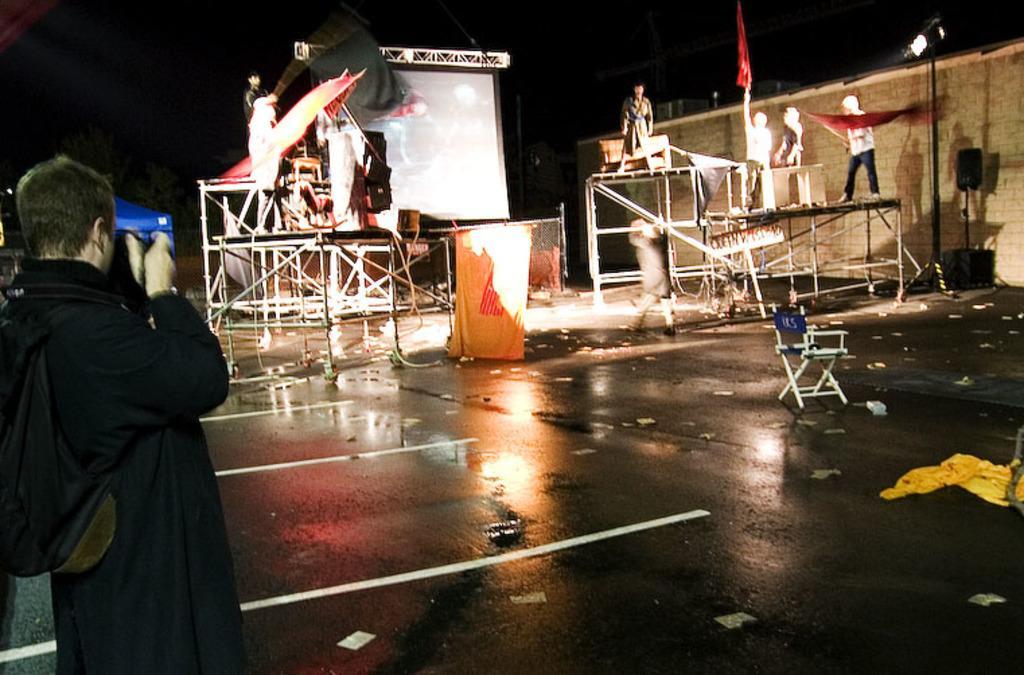How would you summarize this image in a sentence or two? In this image we can see some people standing on the stage holding flags , we can also see a light and speaker placed on stands. In the left side of the image we can see a person holding a camera , a tent and some trees. In the background we can see a screen and metal frame. At the top of the image we can see the sky. 